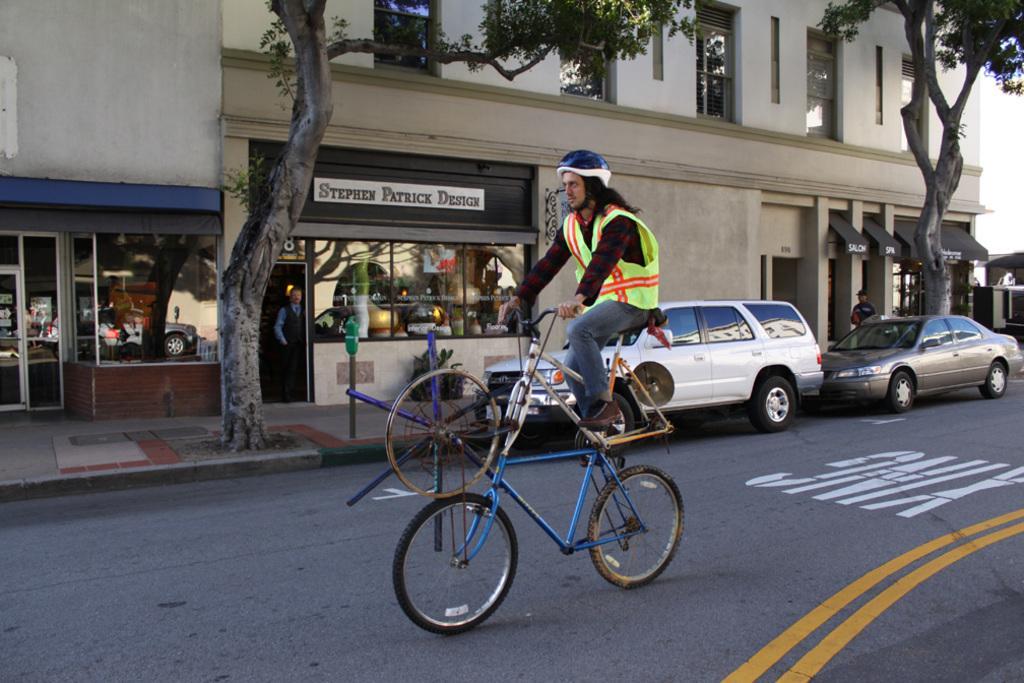Can you describe this image briefly? In this picture I can see a person sitting on a bicycle. In the background I can see buildings, trees, vehicles on the road and people. On the right side I can see sky. 